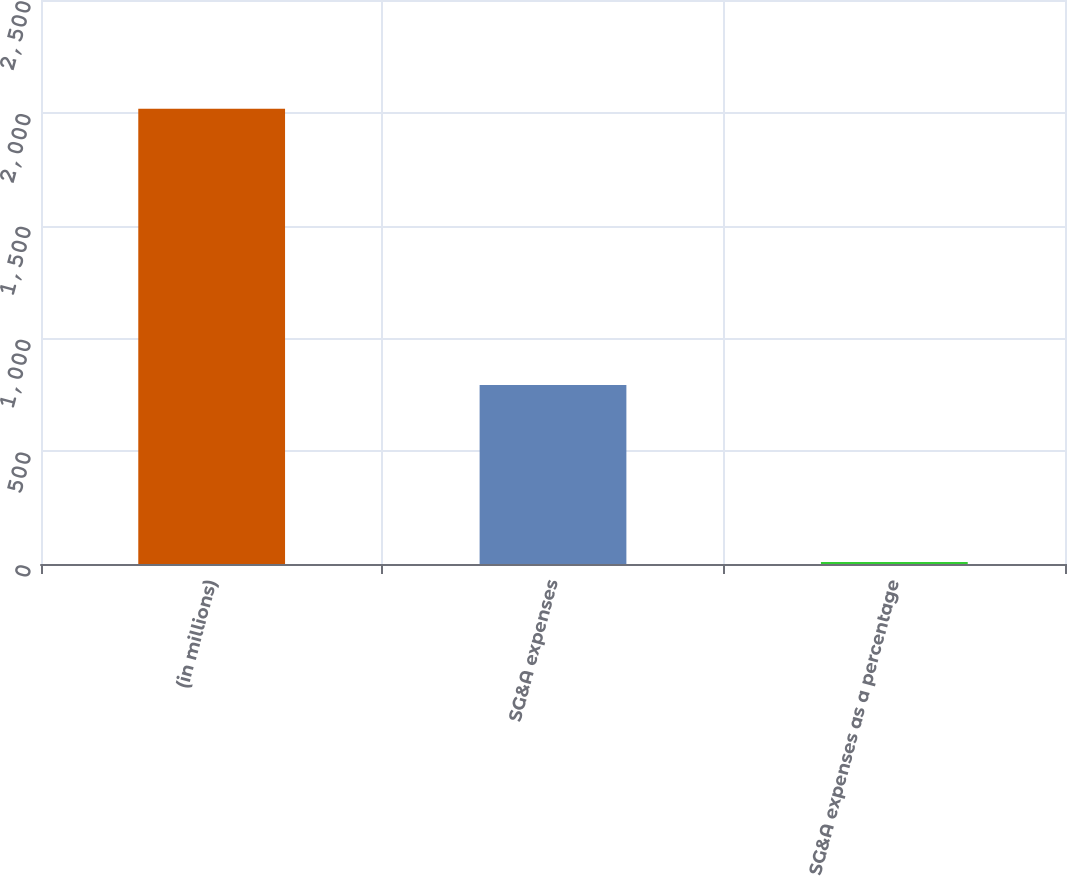<chart> <loc_0><loc_0><loc_500><loc_500><bar_chart><fcel>(in millions)<fcel>SG&A expenses<fcel>SG&A expenses as a percentage<nl><fcel>2018<fcel>793.2<fcel>8.5<nl></chart> 